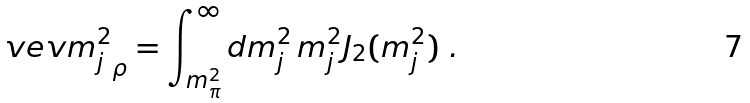<formula> <loc_0><loc_0><loc_500><loc_500>\ v e v { m _ { j } ^ { 2 } } _ { \rho } = \int _ { m _ { \pi } ^ { 2 } } ^ { \infty } d m _ { j } ^ { 2 } \, m _ { j } ^ { 2 } J _ { 2 } ( m _ { j } ^ { 2 } ) \ .</formula> 